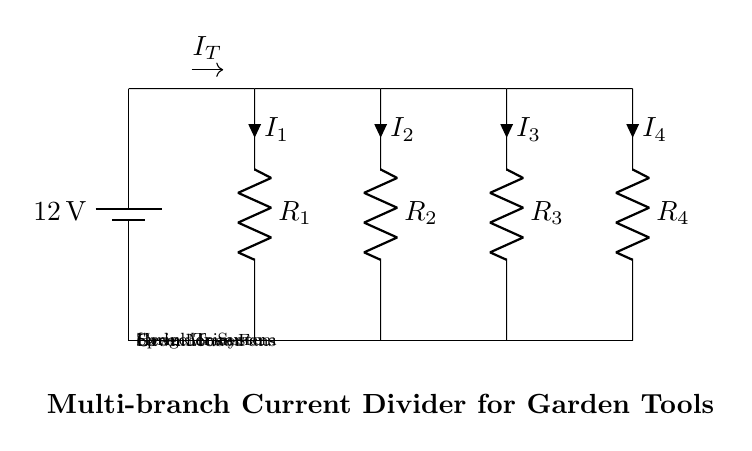What is the total voltage of the circuit? The total voltage is 12 volts as specified by the battery. This is the potential difference across the circuit since all components are connected to the same battery.
Answer: 12 volts What are the names of the components connected to the circuit? The components are the Lawn Mower, Hedge Trimmer, Sprinkler System, and Greenhouse Fans. Each component is represented as a branch with a resistor labeled indicating its function.
Answer: Lawn Mower, Hedge Trimmer, Sprinkler System, Greenhouse Fans How many branches are there in the current divider? There are four branches in the current divider, each supplying power to different garden tools. The branches are differentiated based on the components they are connected to.
Answer: Four What do the resistors in the circuit represent? The resistors represent the load of each garden tool or equipment. Each resistor has a corresponding label that identifies which tool it is associated with, dictating how much current flows through each branch.
Answer: The load of garden tools What is the role of the current divider in this circuit? The current divider allows the total current from the battery to be split between multiple branches, each providing power to different garden tools. This configuration enables efficient use of the battery for multiple operations without overloading a single branch.
Answer: To split the total current Which branch has the highest current? The branch with the lowest resistance will typically have the highest current due to Ohm's Law, but exact values cannot be determined without numerical resistance values for each branch.
Answer: Depends on resistance values What is the notation for the total current entering the branches? The total current entering the branches is denoted as I_T in the diagram, indicating the sum of all branch currents. This notation helps to understand the distribution of current within the circuit.
Answer: I_T 